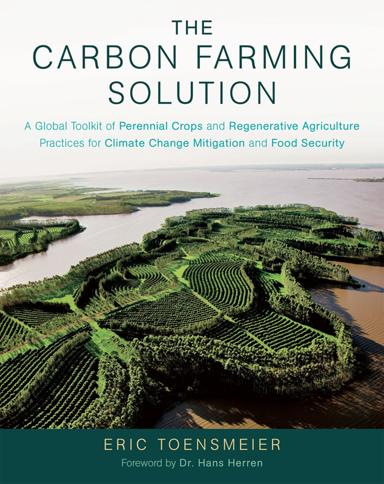What is the title of the book mentioned in the image?
 The title of the book is "The Carbon Farming Solution: A Global Toolkit of Perennial Crops and Regenerative Agriculture Practices for Climate Change Mitigation and Food Security" by Eric Toensmeier. Who wrote the foreword for the book? Dr. Hans Herren wrote the foreword for the book. 